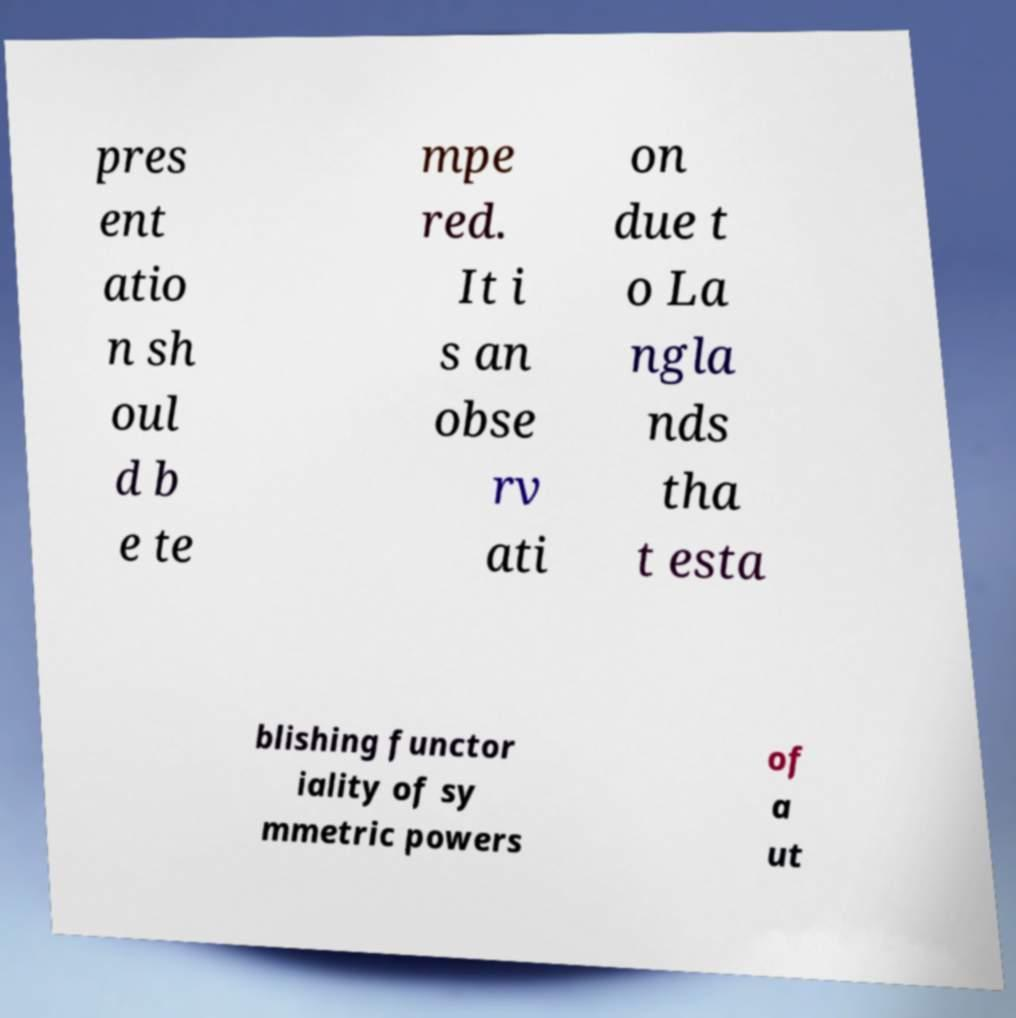Can you accurately transcribe the text from the provided image for me? pres ent atio n sh oul d b e te mpe red. It i s an obse rv ati on due t o La ngla nds tha t esta blishing functor iality of sy mmetric powers of a ut 